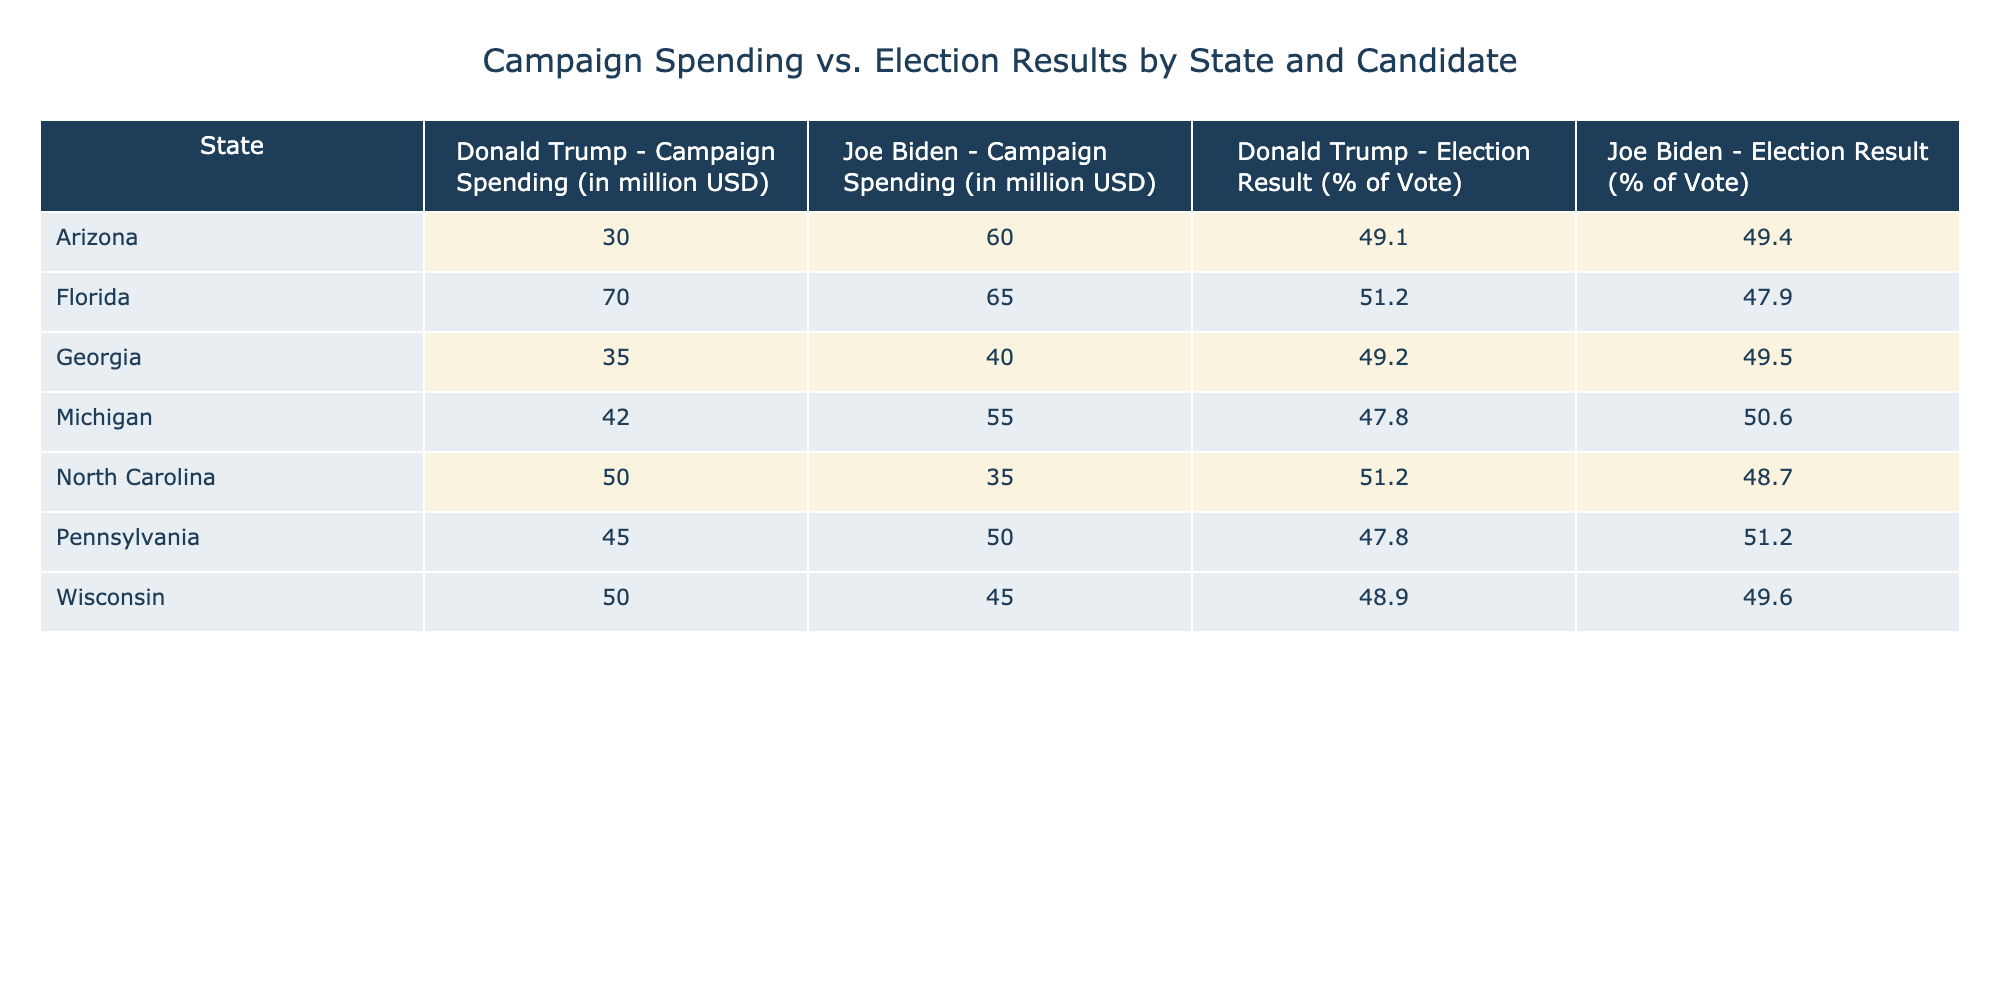What was the campaign spending for Joe Biden in Pennsylvania? According to the table, Joe Biden's campaign spending in Pennsylvania is listed as 50 million USD.
Answer: 50 million USD What percentage of the vote did Donald Trump receive in Georgia? The table indicates that Donald Trump received 49.2% of the vote in Georgia.
Answer: 49.2% Which candidate had higher campaign spending in Florida? The table shows that Joe Biden spent 65 million USD while Donald Trump spent 70 million USD in Florida. Thus, Donald Trump had higher spending.
Answer: Donald Trump What is the total campaign spending by Joe Biden across all listed states? To find Joe Biden's total campaign spending, sum his spending in each state: 50 (PA) + 40 (GA) + 60 (AZ) + 45 (WI) + 55 (MI) + 65 (FL) + 35 (NC) = 350 million USD.
Answer: 350 million USD Did Joe Biden receive more than 50% of the votes in Michigan? The table indicates that Joe Biden received 50.6% of the vote in Michigan, which is indeed more than 50%.
Answer: Yes Which state had the closest percentage of votes between the candidates? The closest vote percentages can be identified by comparing each row's results. The difference in Georgia is 0.3% (49.5% for Biden and 49.2% for Trump), which is the smallest difference among the states listed.
Answer: Georgia What is the average election result percentage for Joe Biden across all states? Joe Biden's election results are: 51.2 (PA) + 49.5 (GA) + 49.4 (AZ) + 49.6 (WI) + 50.6 (MI) + 47.9 (FL) + 48.7 (NC). To calculate the average, sum these values (51.2 + 49.5 + 49.4 + 49.6 + 50.6 + 47.9 + 48.7 =  348.9) and divide by 7, yielding 348.9 / 7 ≈ 49.84%.
Answer: Approximately 49.84% In which state did Donald Trump receive the highest percentage of votes? By examining the table, it is evident that Donald Trump received 51.2% of the votes in both Florida and North Carolina, which are his highest percentages.
Answer: Florida and North Carolina Which candidate had a lower spending in Michigan? In Michigan, Joe Biden spent 55 million USD while Donald Trump spent 42 million USD. Thus, Donald Trump had lower campaign spending.
Answer: Donald Trump 